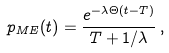<formula> <loc_0><loc_0><loc_500><loc_500>p _ { M E } ( t ) = \frac { e ^ { - \lambda \Theta ( t - T ) } } { T + 1 / \lambda } \, ,</formula> 